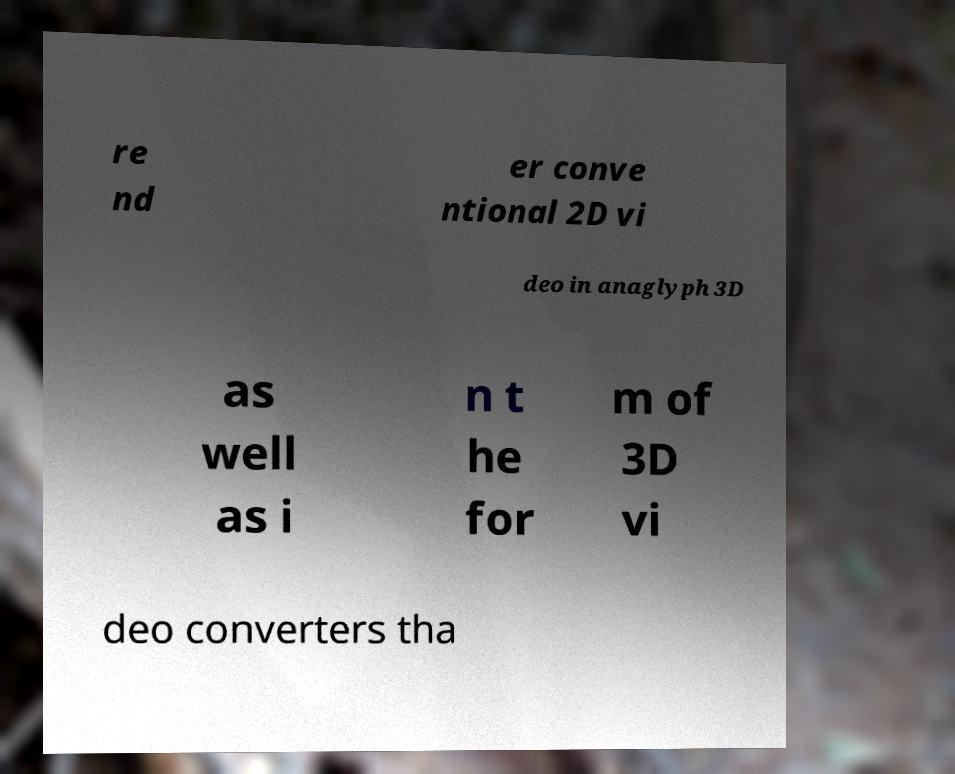Could you extract and type out the text from this image? re nd er conve ntional 2D vi deo in anaglyph 3D as well as i n t he for m of 3D vi deo converters tha 